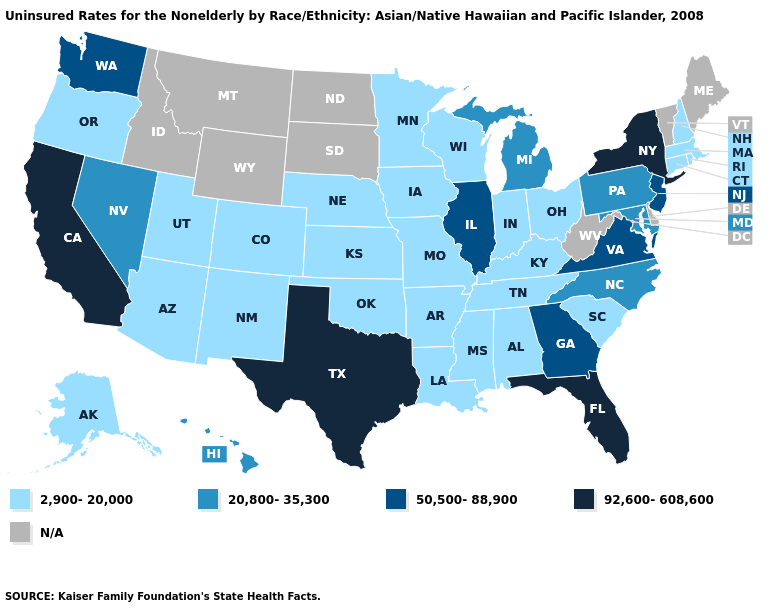Does Illinois have the highest value in the MidWest?
Concise answer only. Yes. Among the states that border Delaware , does New Jersey have the lowest value?
Quick response, please. No. Does Maryland have the lowest value in the USA?
Give a very brief answer. No. Among the states that border West Virginia , does Maryland have the highest value?
Quick response, please. No. Which states hav the highest value in the Northeast?
Concise answer only. New York. What is the value of Rhode Island?
Be succinct. 2,900-20,000. What is the highest value in the USA?
Keep it brief. 92,600-608,600. Is the legend a continuous bar?
Short answer required. No. What is the highest value in the South ?
Quick response, please. 92,600-608,600. What is the value of New York?
Give a very brief answer. 92,600-608,600. What is the value of Kentucky?
Be succinct. 2,900-20,000. Does Mississippi have the highest value in the South?
Quick response, please. No. What is the lowest value in the USA?
Answer briefly. 2,900-20,000. Name the states that have a value in the range 2,900-20,000?
Answer briefly. Alabama, Alaska, Arizona, Arkansas, Colorado, Connecticut, Indiana, Iowa, Kansas, Kentucky, Louisiana, Massachusetts, Minnesota, Mississippi, Missouri, Nebraska, New Hampshire, New Mexico, Ohio, Oklahoma, Oregon, Rhode Island, South Carolina, Tennessee, Utah, Wisconsin. 